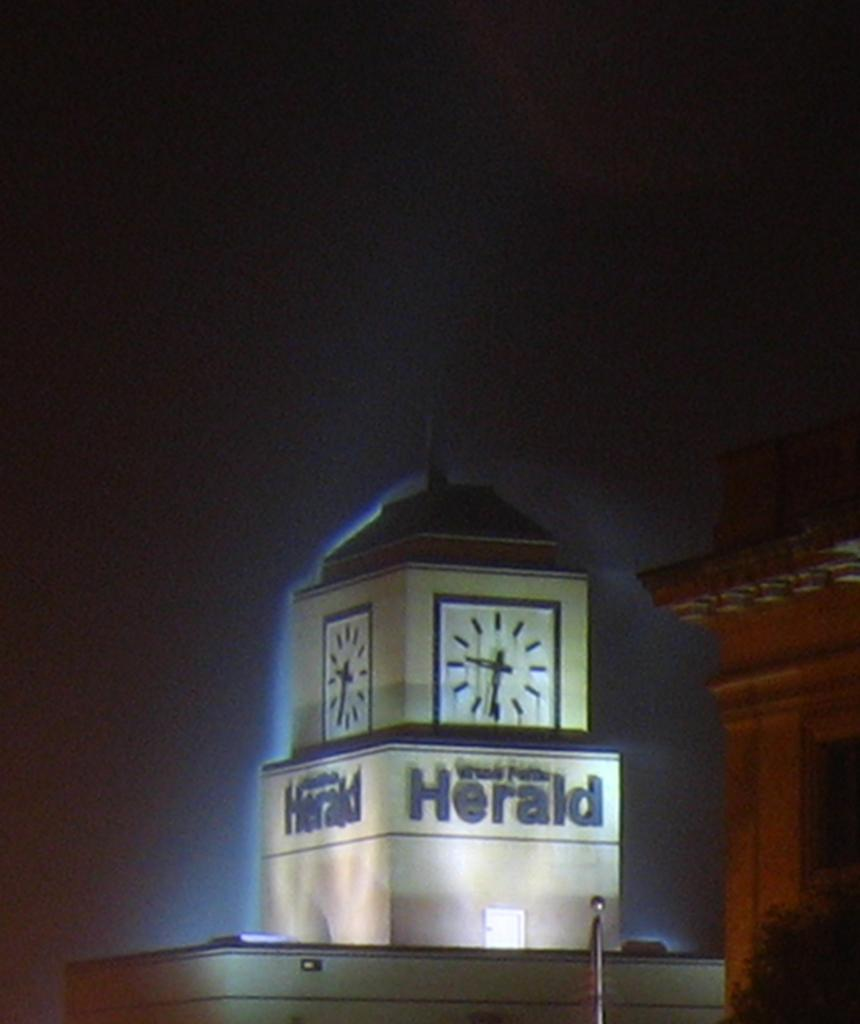<image>
Relay a brief, clear account of the picture shown. Building with a clock and the words "Herald" under it. 